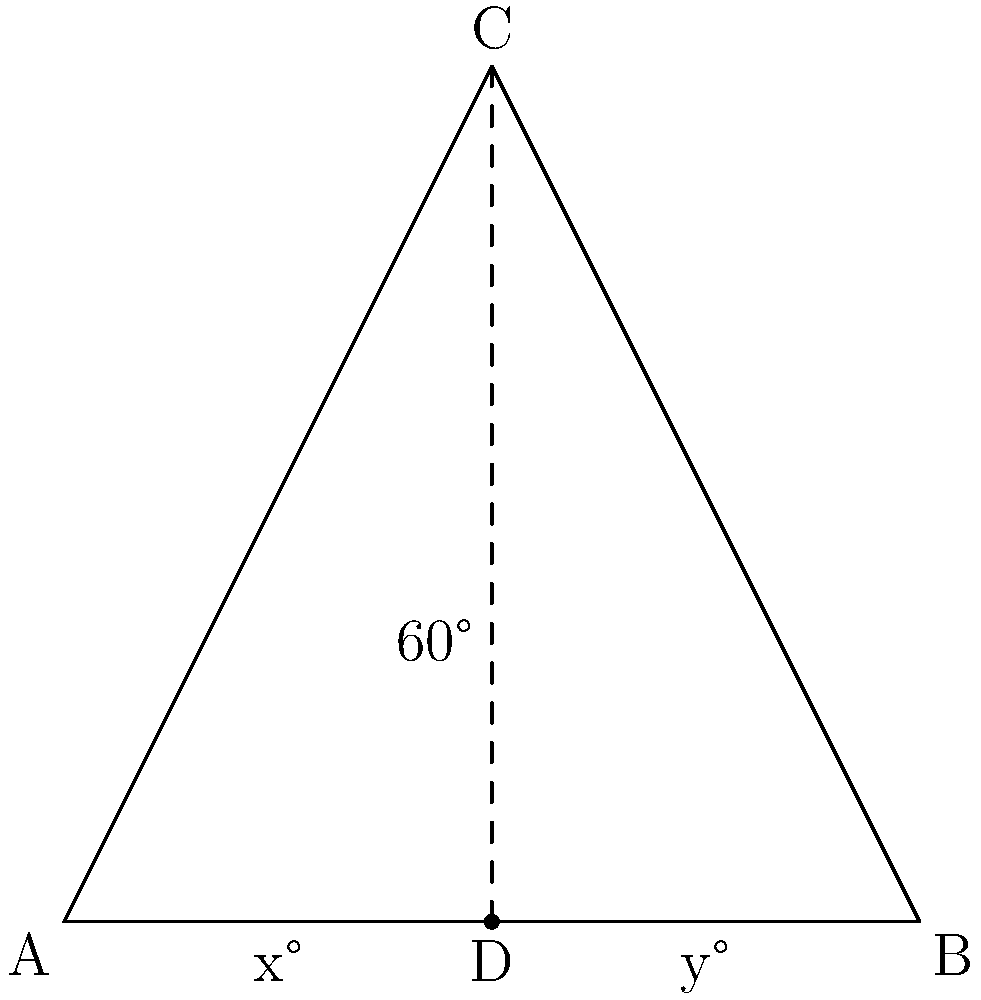Two surveillance drones are tracking separate flight paths that intersect over an international border. The paths form a triangle ABC with the border line. If angle C is 60°, and the other two angles are represented by x° and y°, determine the value of x + y. To solve this problem, we'll use the properties of triangles and the sum of angles in a triangle. Let's approach this step-by-step:

1) In any triangle, the sum of all internal angles is always 180°.

2) We're given that angle C is 60°, and the other two angles are x° and y°.

3) We can express this as an equation:
   $$x° + y° + 60° = 180°$$

4) To find x + y, we need to isolate these terms:
   $$x° + y° = 180° - 60°$$

5) Simplifying the right side:
   $$x° + y° = 120°$$

6) Therefore, the sum of x and y is 120°.
Answer: 120° 